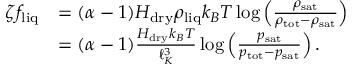<formula> <loc_0><loc_0><loc_500><loc_500>\begin{array} { r l } { \zeta f _ { l i q } } & { = ( \alpha - 1 ) H _ { d r y } \rho _ { l i q } k _ { B } T \log \left ( \frac { \rho _ { s a t } } { \rho _ { t o t } - \rho _ { s a t } } \right ) } \\ & { = ( \alpha - 1 ) \frac { H _ { d r y } k _ { B } T } { \ell _ { K } ^ { 3 } } \log \left ( \frac { p _ { s a t } } { p _ { t o t } - p _ { s a t } } \right ) . } \end{array}</formula> 